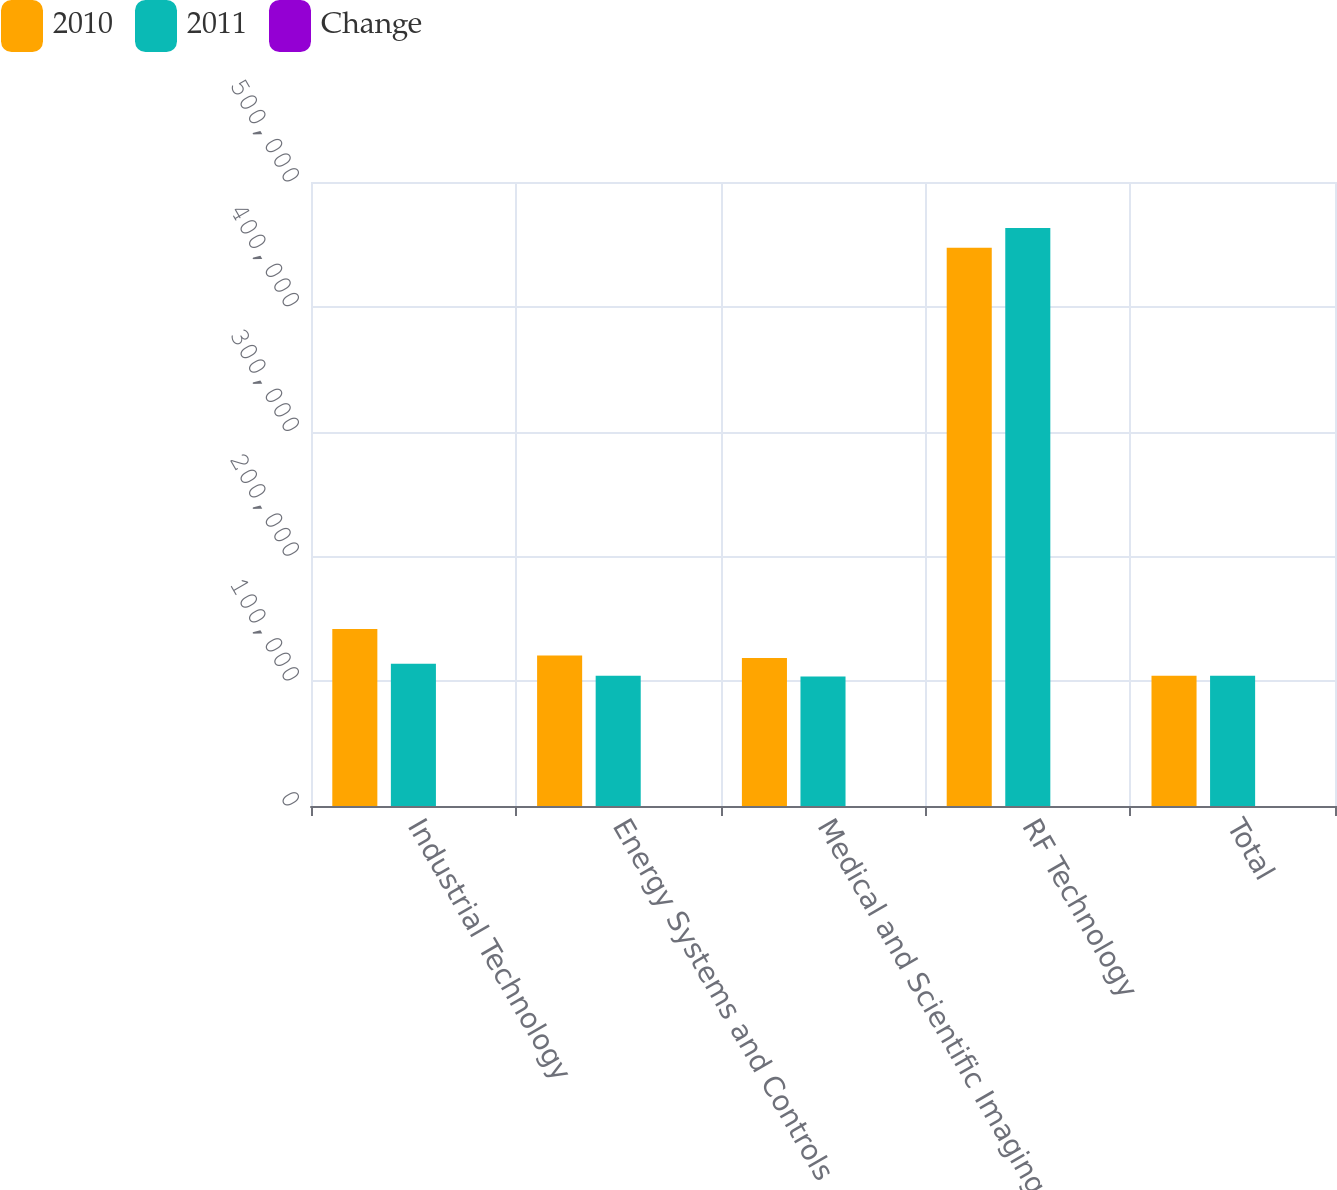Convert chart to OTSL. <chart><loc_0><loc_0><loc_500><loc_500><stacked_bar_chart><ecel><fcel>Industrial Technology<fcel>Energy Systems and Controls<fcel>Medical and Scientific Imaging<fcel>RF Technology<fcel>Total<nl><fcel>2010<fcel>141836<fcel>120497<fcel>118609<fcel>447355<fcel>104466<nl><fcel>2011<fcel>113981<fcel>104466<fcel>103796<fcel>463115<fcel>104466<nl><fcel>Change<fcel>24.4<fcel>15.3<fcel>14.3<fcel>3.4<fcel>5.5<nl></chart> 